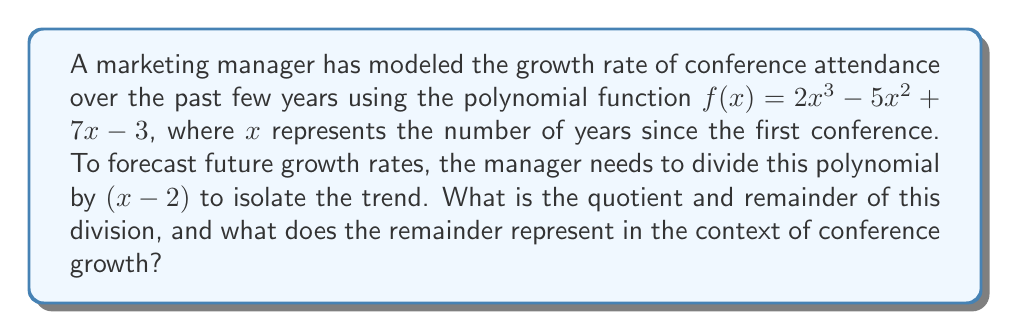Provide a solution to this math problem. Let's perform polynomial long division of $f(x) = 2x^3 - 5x^2 + 7x - 3$ by $(x - 2)$:

$$\begin{array}{r}
2x^2 + 1x + 9 \\
x - 2 \enclose{longdiv}{2x^3 - 5x^2 + 7x - 3} \\
\underline{2x^3 - 4x^2} \\
-x^2 + 7x \\
\underline{-x^2 + 2x} \\
5x - 3 \\
\underline{5x - 10} \\
7
\end{array}$$

Step 1: Divide $2x^3$ by $x$, getting $2x^2$.
Step 2: Multiply $(x - 2)$ by $2x^2$ and subtract from $2x^3 - 5x^2$.
Step 3: Bring down $7x$.
Step 4: Divide $-x^2$ by $x$, getting $-x$.
Step 5: Multiply $(x - 2)$ by $-x$ and subtract from $-x^2 + 7x$.
Step 6: Bring down $-3$.
Step 7: Divide $5x$ by $x$, getting $5$.
Step 8: Multiply $(x - 2)$ by $5$ and subtract from $5x - 3$.

The quotient is $2x^2 + x + 9$, and the remainder is $7$.

In the context of conference growth, the quotient $2x^2 + x + 9$ represents the general trend of growth over time. The remainder of 7 indicates that there's a constant factor of 7 additional attendees that doesn't fit the general trend, possibly representing a core group of loyal attendees or a baseline attendance level.
Answer: Quotient: $2x^2 + x + 9$, Remainder: $7$ 